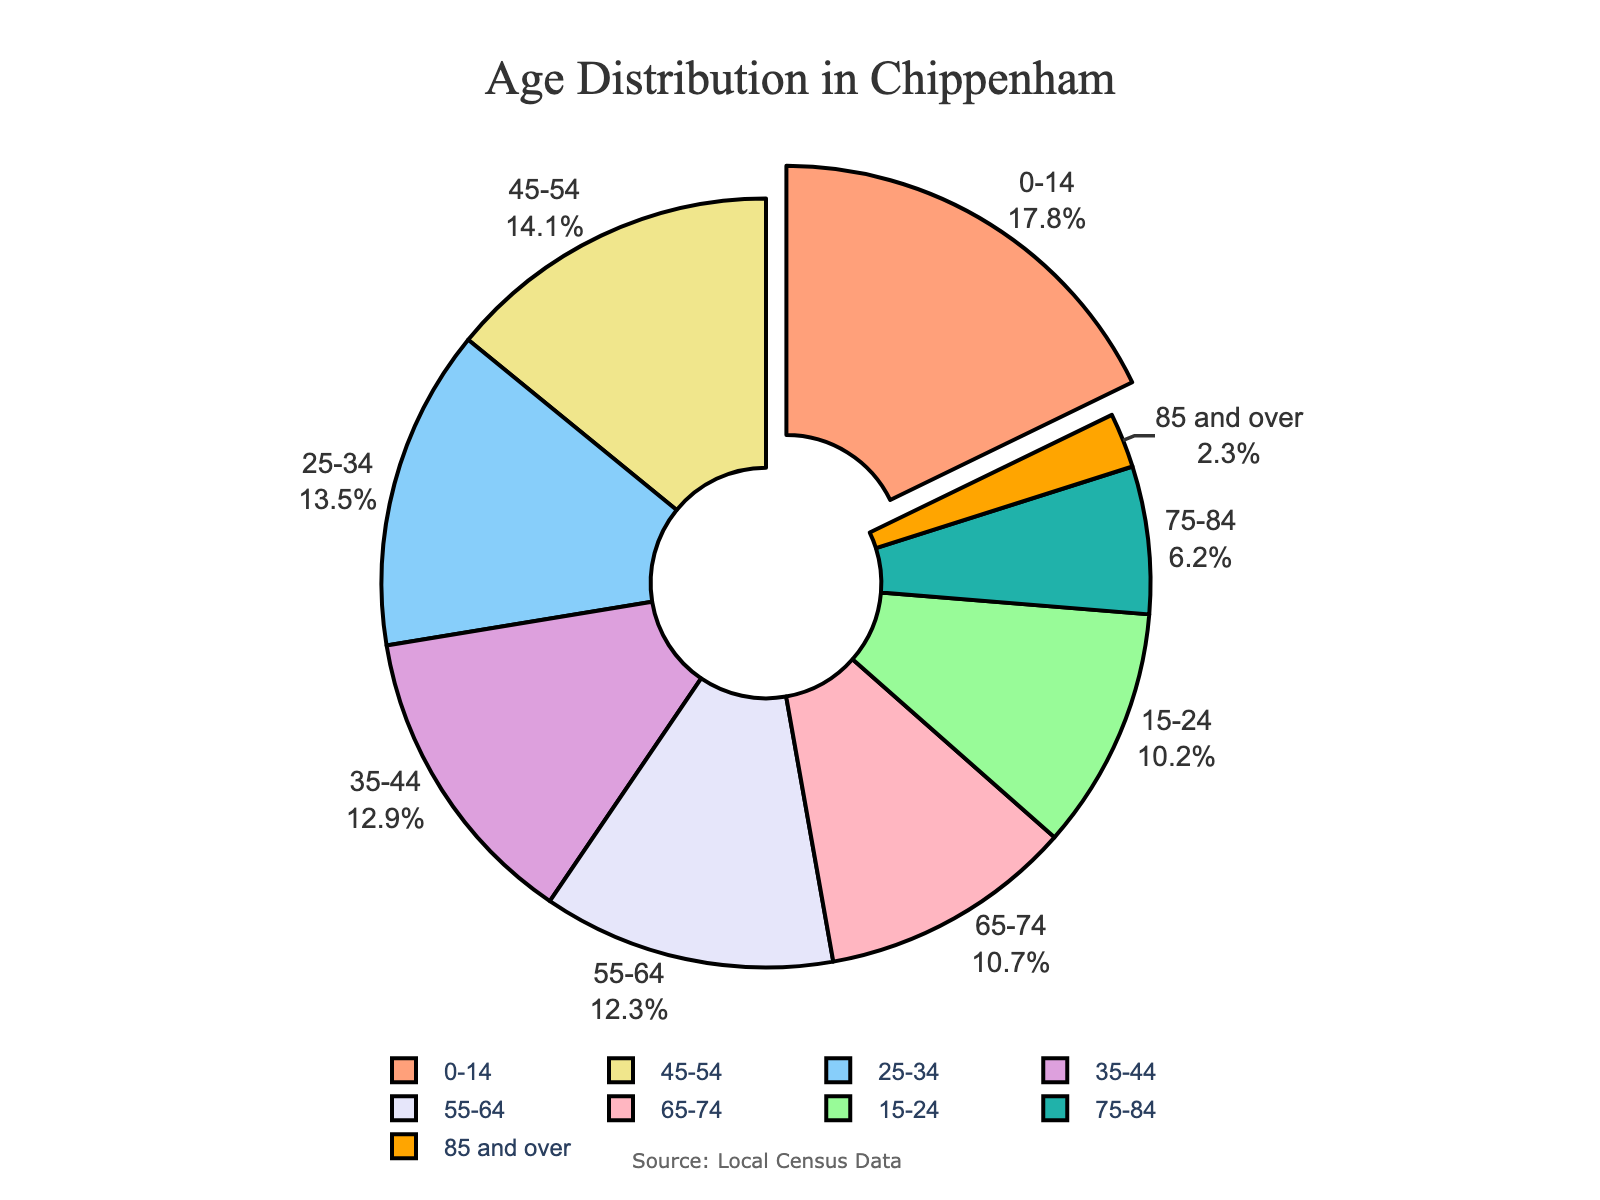What is the largest age group in Chippenham? The largest age group can be identified by looking at the segment that is pulled out from the pie chart. The segment pulled out is labeled "0-14" with a percentage of 17.8%.
Answer: 0-14 What is the combined percentage of the age groups 0-14 and 65 and over? Sum the percentages of the 0-14 age group (17.8%) and the combined percentages of the 65-74 (10.7%), 75-84 (6.2%), and 85 and over (2.3%) groups. 17.8% + 10.7% + 6.2% + 2.3% = 37.0%.
Answer: 37.0% Which age group is smaller: 15-24 or 55-64? Compare the percentages of the 15-24 (10.2%) and 55-64 (12.3%) age groups. The 15-24 group is smaller.
Answer: 15-24 What is the color representing the 25-34 age group? Look at the color corresponding to the 25-34 age segment in the pie chart. The 25-34 age group is represented by a light blue color.
Answer: Light blue Which two age groups have a combined percentage that is closest to 25%? Look for two groups whose combined percentages are close to 25%. The 15-24 (10.2%) and 55-64 (12.3%) groups combined give approximately 22.5%.
Answer: 15-24 and 55-64 What percentage of Chippenham’s population is 45-64 years old? Combine the percentages of the 45-54 (14.1%) and 55-64 (12.3%) age groups. 14.1% + 12.3% = 26.4%.
Answer: 26.4% Which age group has a value that is more than a tenth of the total population? Identify age groups with percentages greater than 10%. The groups are 0-14 (17.8%), 15-24 (10.2%), 25-34 (13.5%), 35-44 (12.9%), 45-54 (14.1%), 55-64 (12.3%), and 65-74 (10.7%).
Answer: Multiple groups (list provided in explanation) 